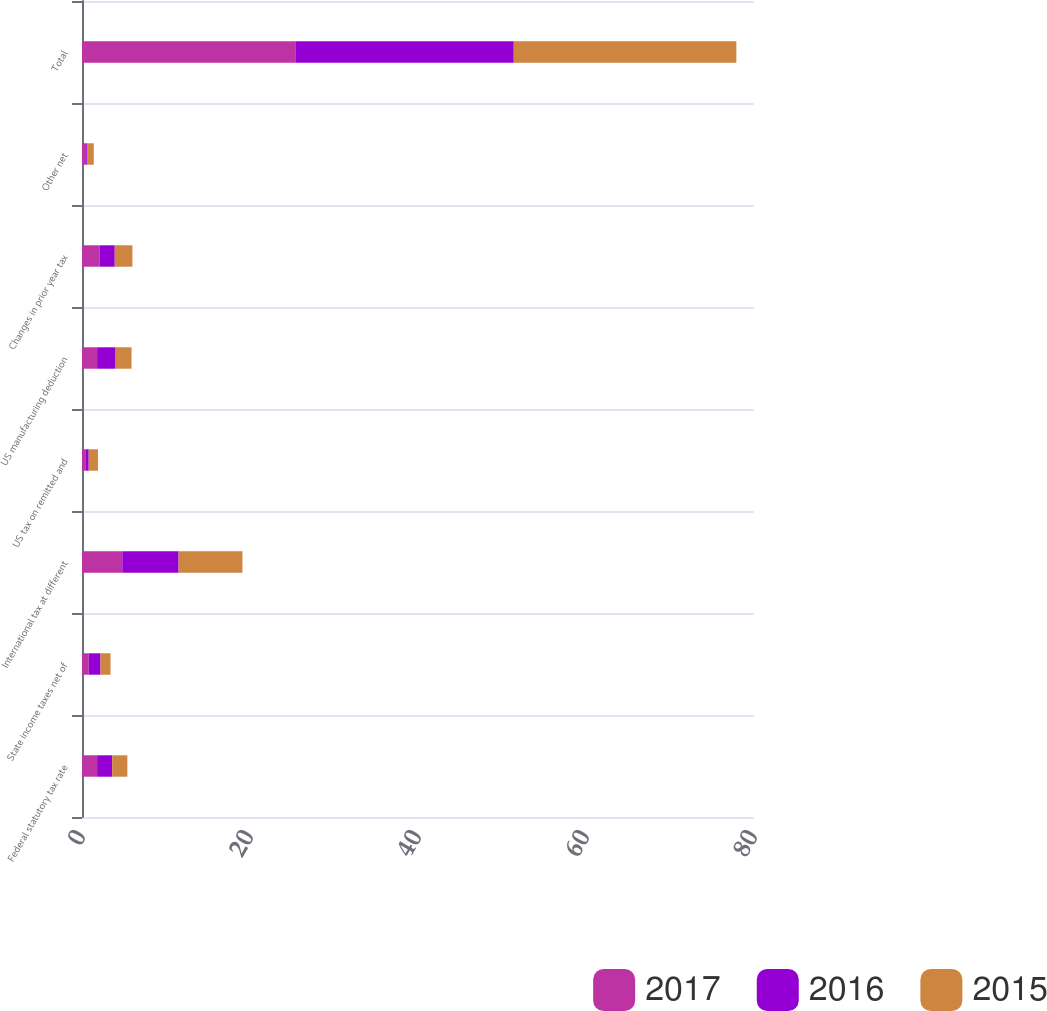Convert chart to OTSL. <chart><loc_0><loc_0><loc_500><loc_500><stacked_bar_chart><ecel><fcel>Federal statutory tax rate<fcel>State income taxes net of<fcel>International tax at different<fcel>US tax on remitted and<fcel>US manufacturing deduction<fcel>Changes in prior year tax<fcel>Other net<fcel>Total<nl><fcel>2017<fcel>1.8<fcel>0.8<fcel>4.8<fcel>0.4<fcel>1.8<fcel>2.1<fcel>0.5<fcel>25.4<nl><fcel>2016<fcel>1.8<fcel>1.4<fcel>6.7<fcel>0.4<fcel>2.2<fcel>1.8<fcel>0.1<fcel>26<nl><fcel>2015<fcel>1.8<fcel>1.2<fcel>7.6<fcel>1.1<fcel>1.9<fcel>2.1<fcel>0.8<fcel>26.5<nl></chart> 